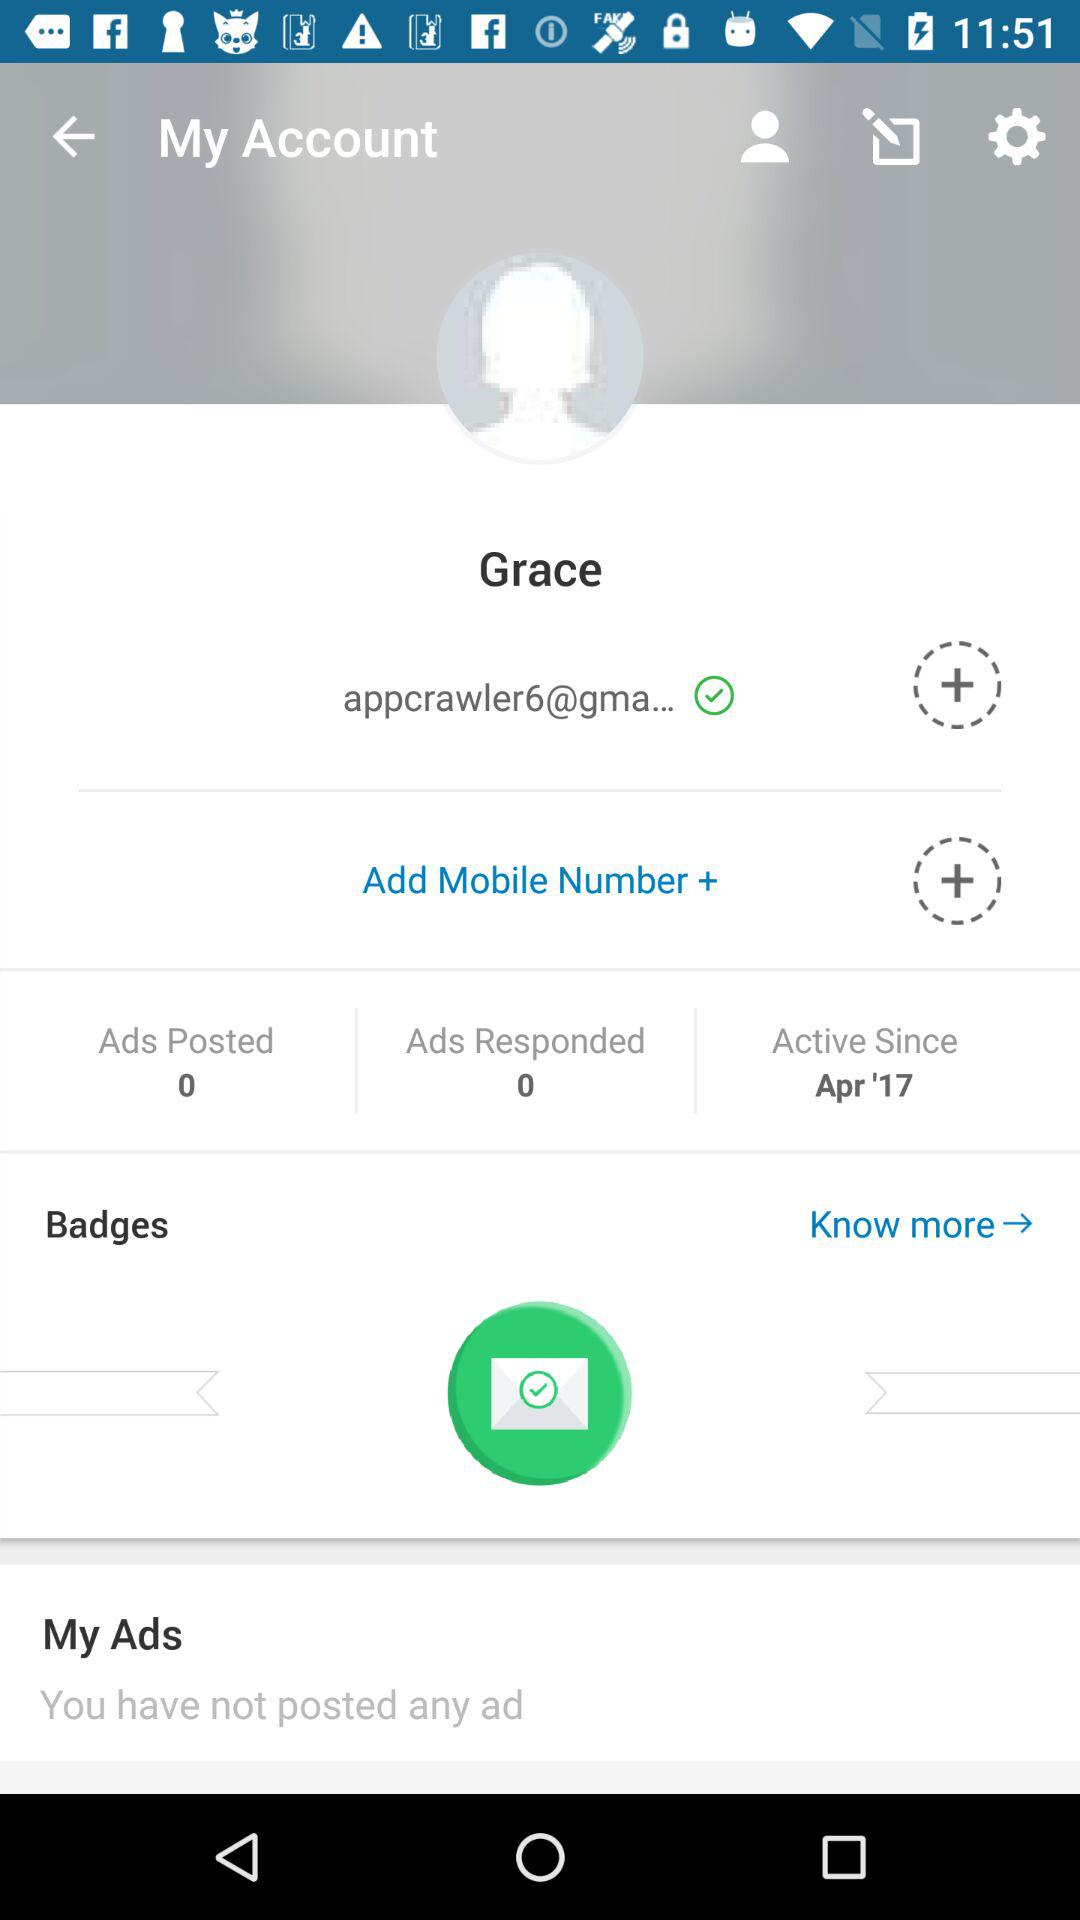Is the email address verified or not?
Answer the question using a single word or phrase. It is verified. 